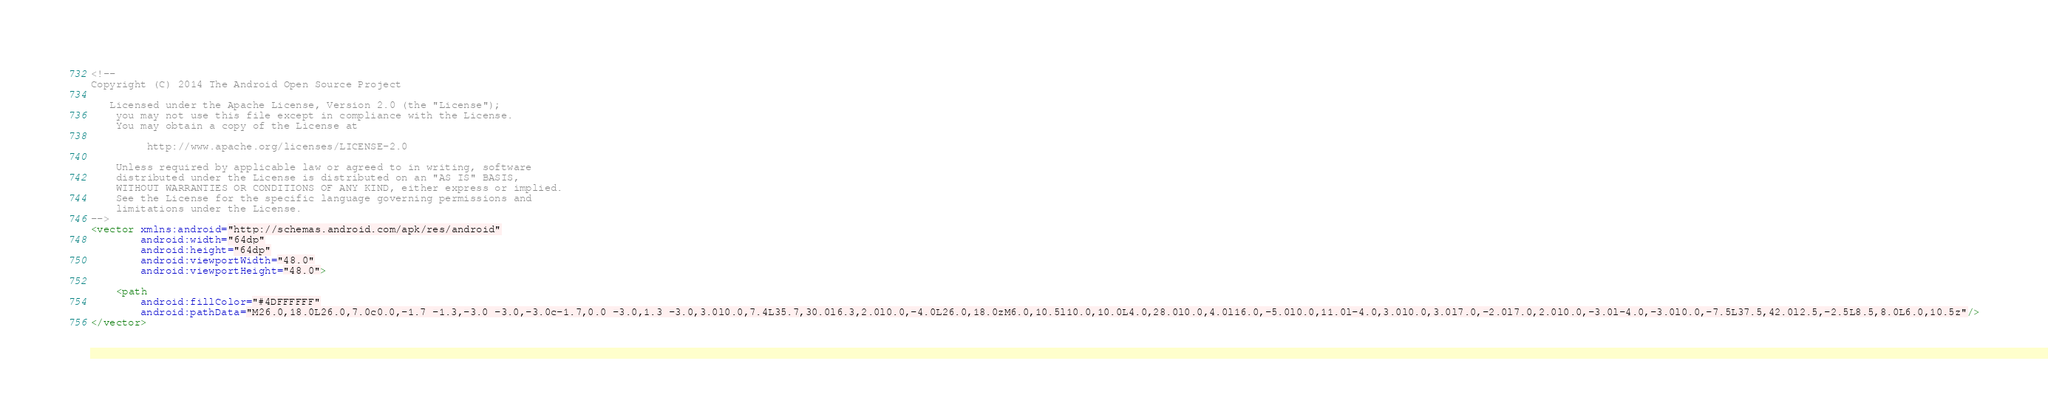Convert code to text. <code><loc_0><loc_0><loc_500><loc_500><_XML_><!--
Copyright (C) 2014 The Android Open Source Project

   Licensed under the Apache License, Version 2.0 (the "License");
    you may not use this file except in compliance with the License.
    You may obtain a copy of the License at

         http://www.apache.org/licenses/LICENSE-2.0

    Unless required by applicable law or agreed to in writing, software
    distributed under the License is distributed on an "AS IS" BASIS,
    WITHOUT WARRANTIES OR CONDITIONS OF ANY KIND, either express or implied.
    See the License for the specific language governing permissions and
    limitations under the License.
-->
<vector xmlns:android="http://schemas.android.com/apk/res/android"
        android:width="64dp"
        android:height="64dp"
        android:viewportWidth="48.0"
        android:viewportHeight="48.0">

    <path
        android:fillColor="#4DFFFFFF"
        android:pathData="M26.0,18.0L26.0,7.0c0.0,-1.7 -1.3,-3.0 -3.0,-3.0c-1.7,0.0 -3.0,1.3 -3.0,3.0l0.0,7.4L35.7,30.0l6.3,2.0l0.0,-4.0L26.0,18.0zM6.0,10.5l10.0,10.0L4.0,28.0l0.0,4.0l16.0,-5.0l0.0,11.0l-4.0,3.0l0.0,3.0l7.0,-2.0l7.0,2.0l0.0,-3.0l-4.0,-3.0l0.0,-7.5L37.5,42.0l2.5,-2.5L8.5,8.0L6.0,10.5z"/>
</vector>
</code> 